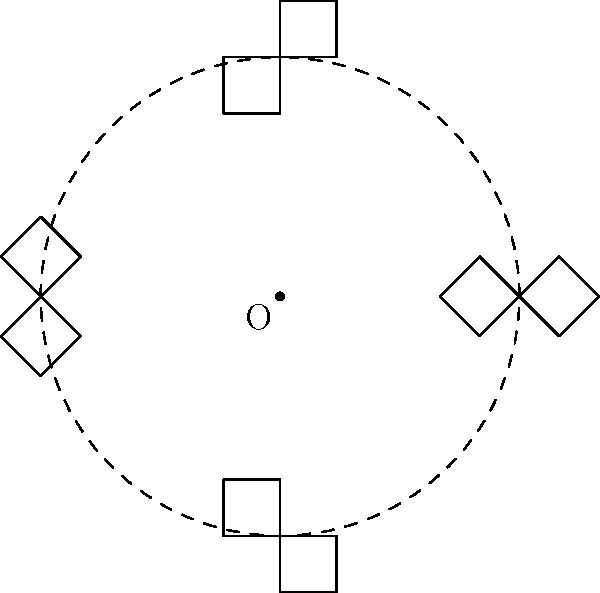As a front-end web developer specializing in Drupal theming and design, you're tasked with creating a circular pattern for a client's website using their logo. The logo needs to be rotated around a fixed point to create this pattern. Given the diagram above, where a simple logo shape is rotated 8 times around the origin O to form a circular pattern, what is the angle of rotation between each instance of the logo? To determine the angle of rotation between each instance of the logo, we can follow these steps:

1. Observe that the logo forms a complete circular pattern.
2. A full circle contains 360°.
3. Count the number of times the logo appears in the pattern. In this case, there are 8 instances of the logo.
4. To find the angle between each logo, divide the total degrees in a circle by the number of logo instances:

   $$\text{Angle of rotation} = \frac{\text{Total degrees in a circle}}{\text{Number of logo instances}}$$
   
   $$\text{Angle of rotation} = \frac{360°}{8} = 45°$$

Therefore, the angle of rotation between each instance of the logo is 45°.

This rotation technique is commonly used in web design to create radial patterns or circular navigation elements, which can be implemented using CSS transforms in front-end development.
Answer: 45° 